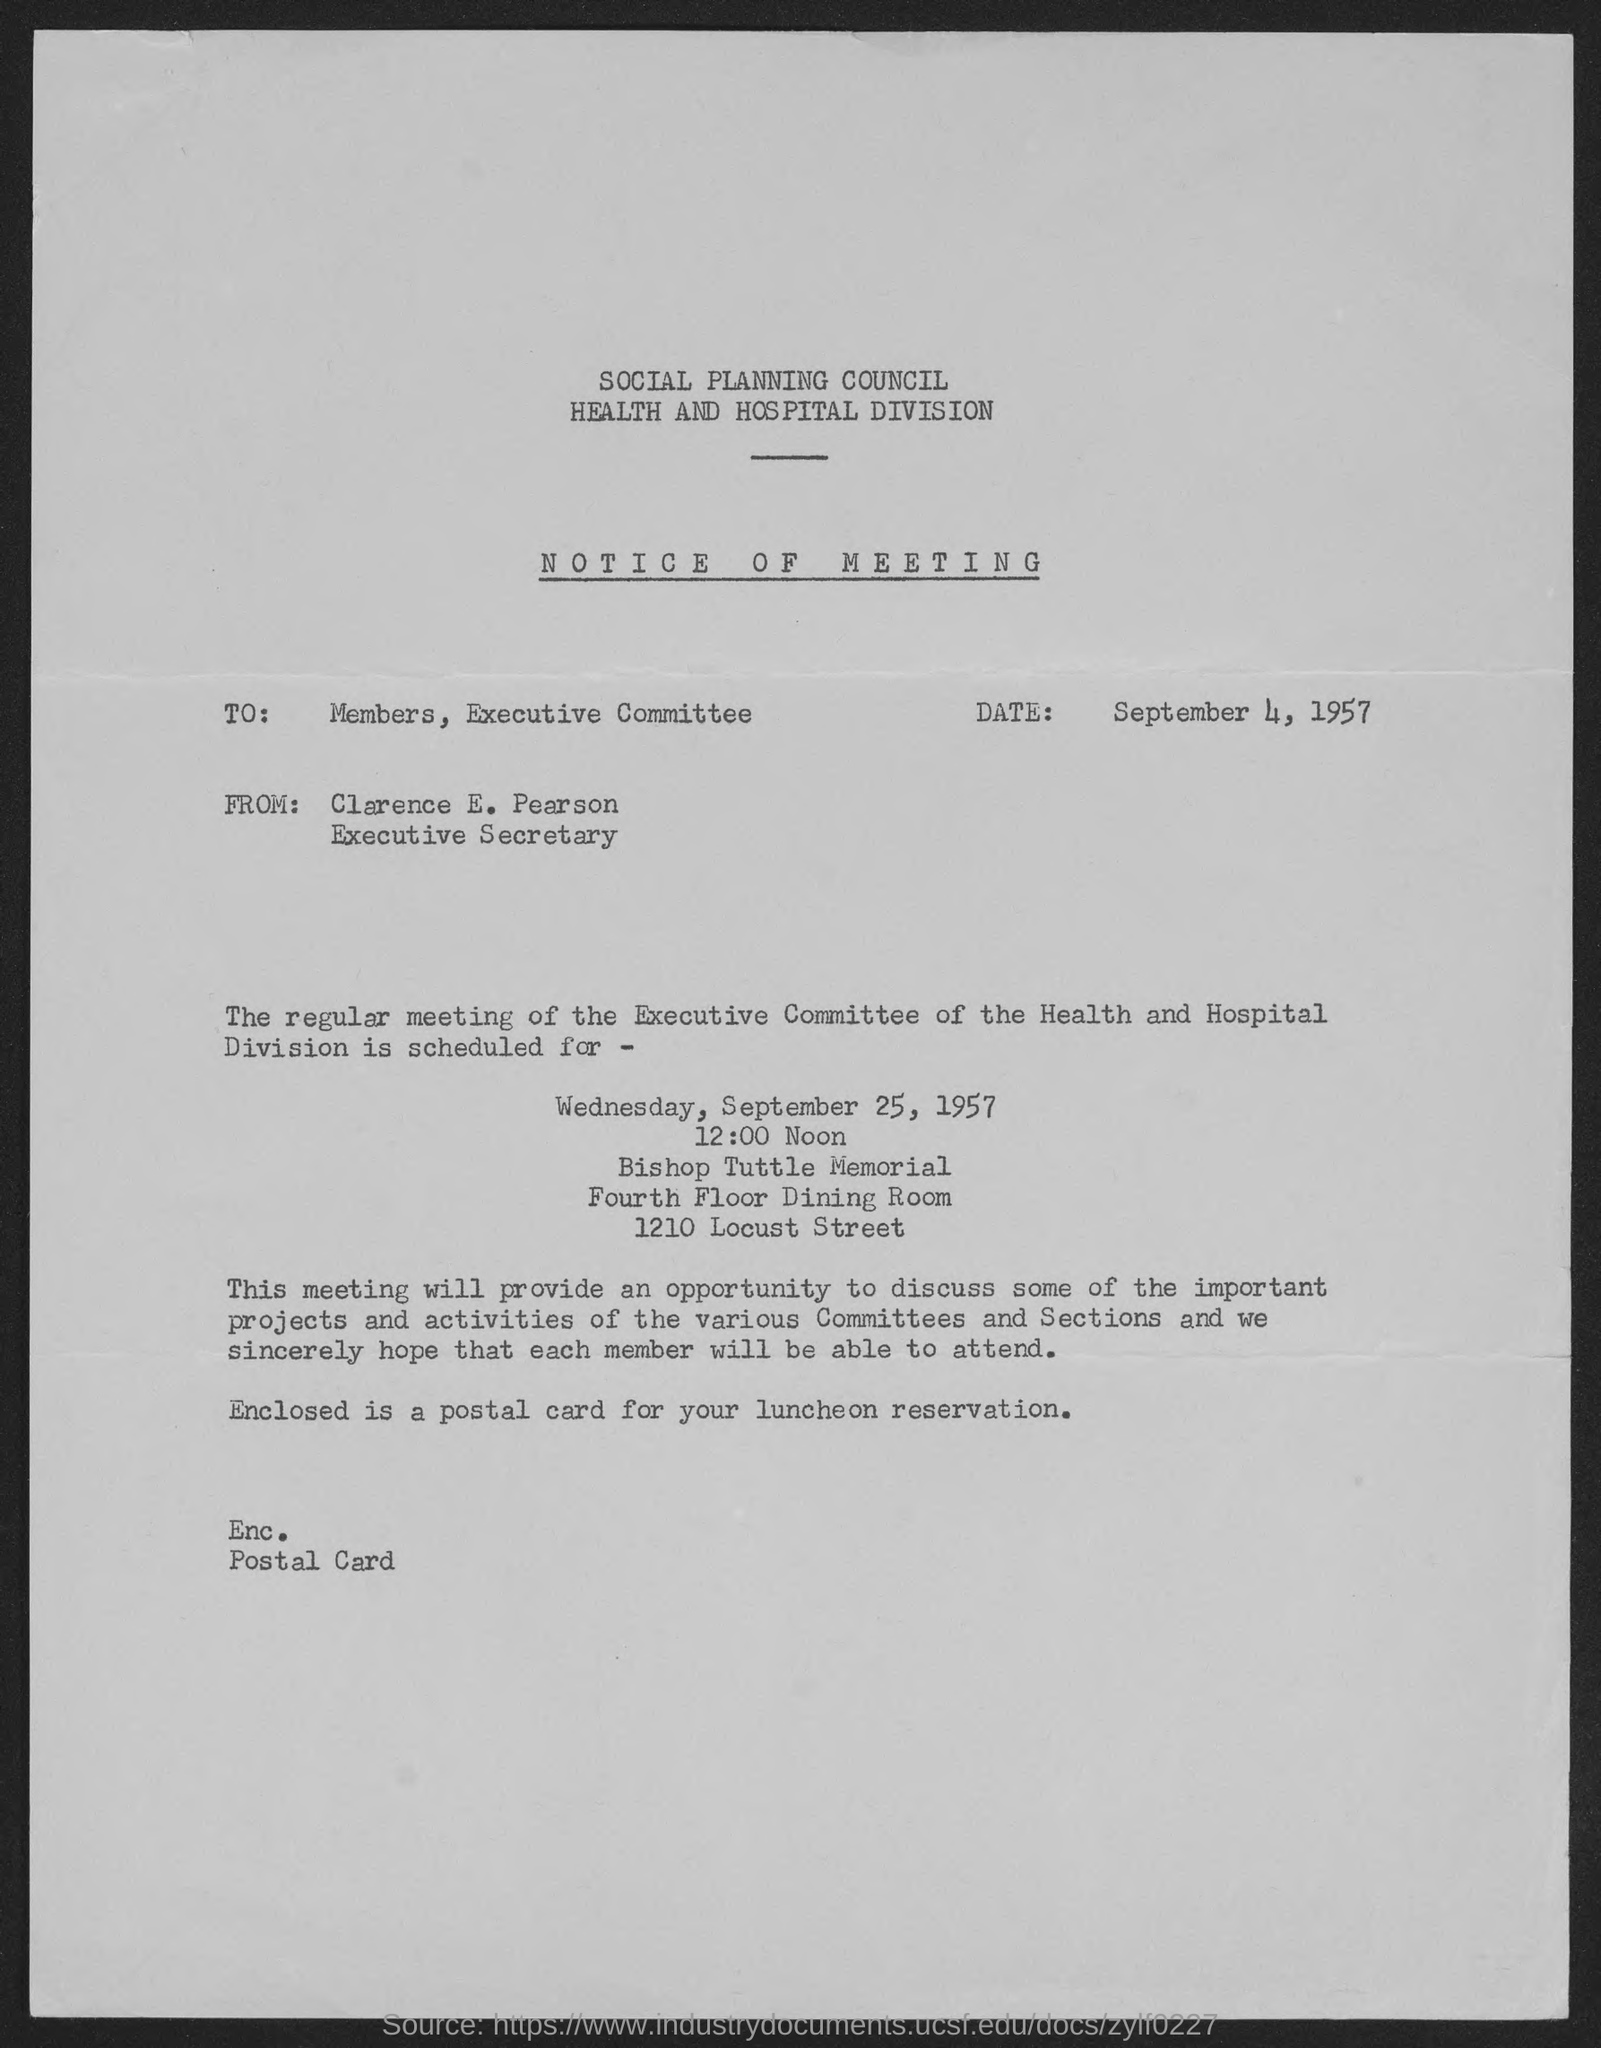Indicate a few pertinent items in this graphic. The regular meeting of the executive committee of the Health and Hospital Division is scheduled for September 25, 1957. The street address of Bishop Tuttle Memorial is 1210 Locust Street. The meeting is scheduled for Wednesday. The notice is dated on September 4, 1957. The Notice of Meeting is from Clarence E. Pearson. 